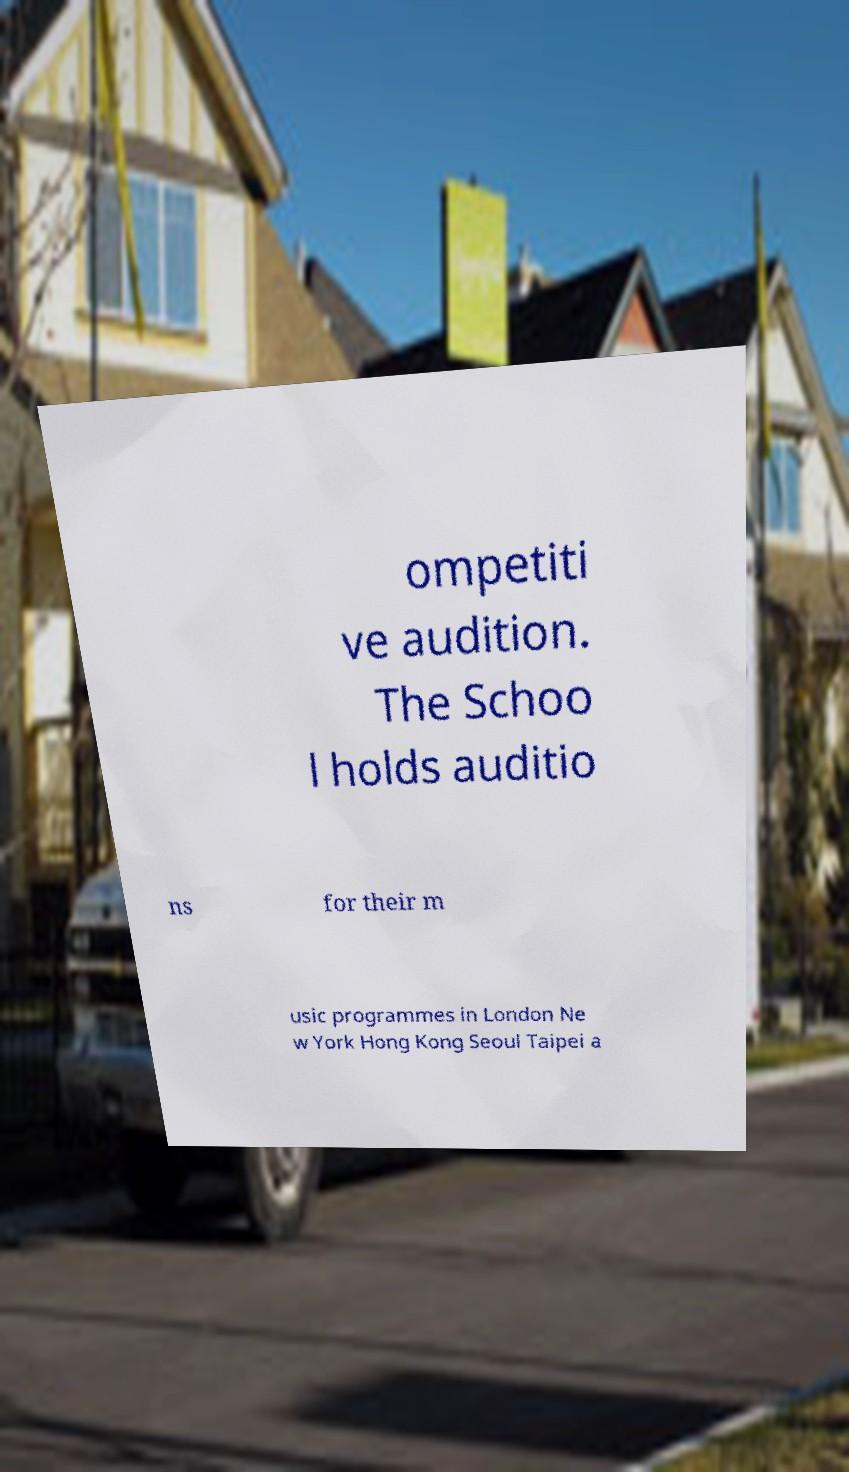There's text embedded in this image that I need extracted. Can you transcribe it verbatim? ompetiti ve audition. The Schoo l holds auditio ns for their m usic programmes in London Ne w York Hong Kong Seoul Taipei a 